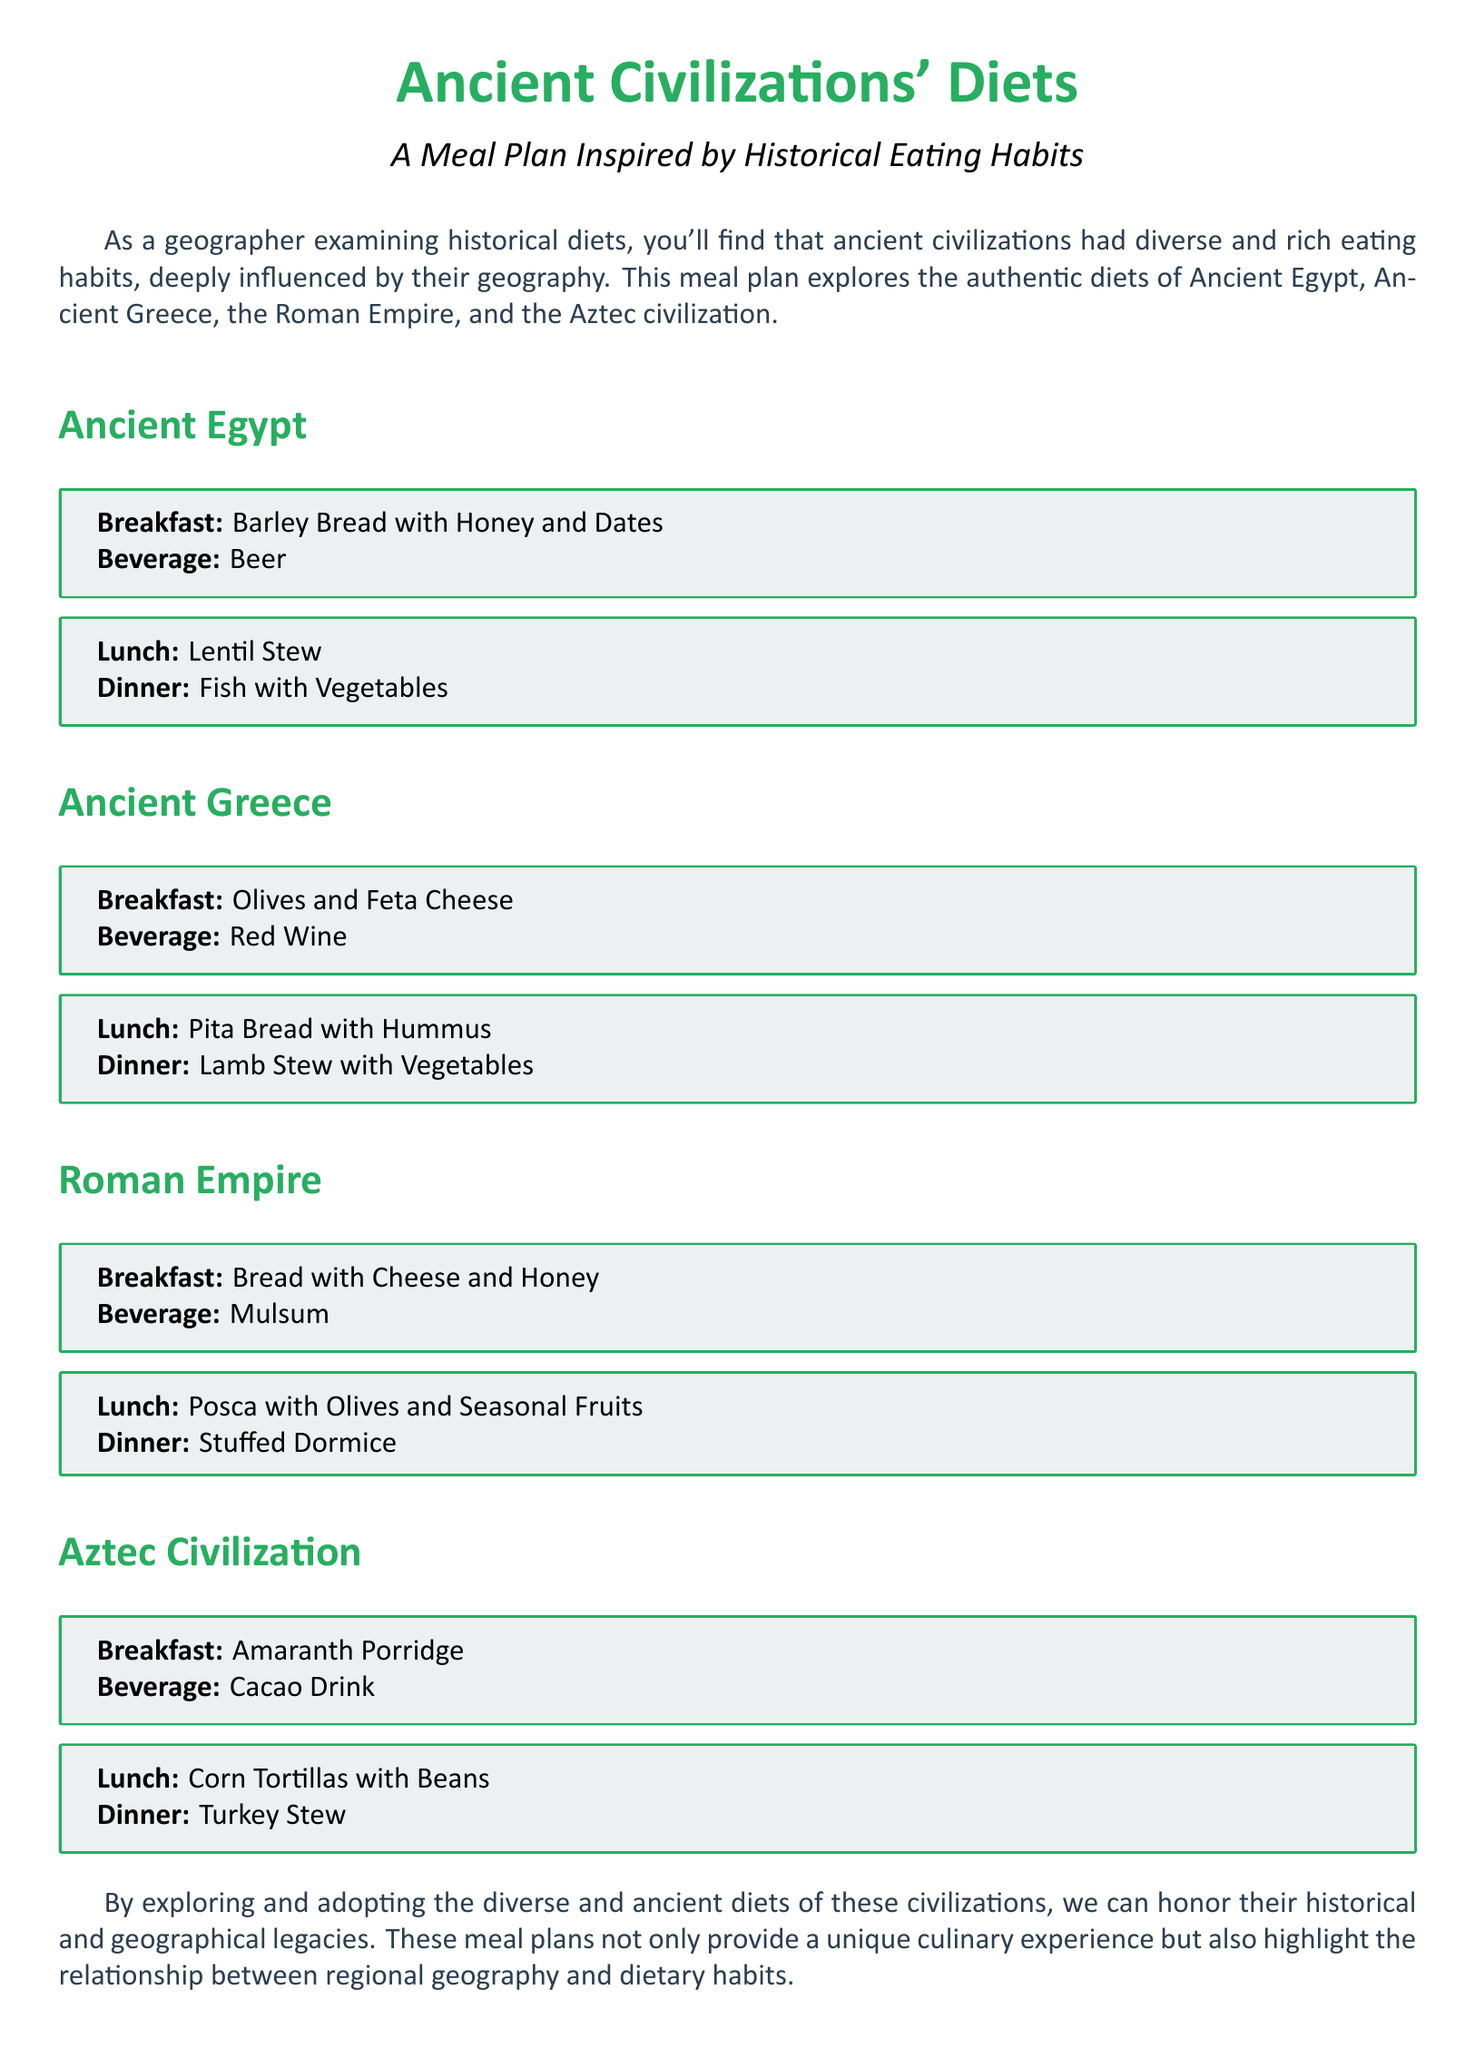What is the breakfast option for Ancient Greece? The breakfast option for Ancient Greece is olives and feta cheese.
Answer: Olives and Feta Cheese What beverage is served with the Ancient Egyptian breakfast? The beverage served with the Ancient Egyptian breakfast is beer.
Answer: Beer Which civilization's lunch includes corn tortillas with beans? Corn tortillas with beans is the lunch option of the Aztec civilization.
Answer: Aztec civilization How many dinner options are listed for the Roman Empire? There are two dinner options listed for the Roman Empire: stuffed dormice and fish with vegetables.
Answer: One What is the main ingredient in the Ancient Egyptian lunch? The main ingredient in the Ancient Egyptian lunch is lentils.
Answer: Lentil Which civilization is known for its use of cacao in a breakfast drink? The civilization known for its use of cacao in a breakfast drink is the Aztec civilization.
Answer: Aztec civilization What kind of stew is included in the Ancient Greek dinner? The type of stew included in the Ancient Greek dinner is lamb stew with vegetables.
Answer: Lamb Stew with Vegetables What type of meal plan does this document describe? The document describes a meal plan inspired by historical eating habits.
Answer: Meal Plan Inspired by Historical Eating Habits What is a common beverage served with meals in the Roman Empire? A common beverage served with meals in the Roman Empire is mulsum.
Answer: Mulsum 